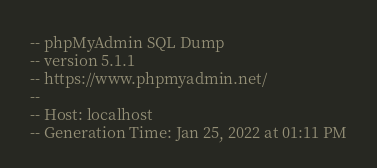<code> <loc_0><loc_0><loc_500><loc_500><_SQL_>-- phpMyAdmin SQL Dump
-- version 5.1.1
-- https://www.phpmyadmin.net/
--
-- Host: localhost
-- Generation Time: Jan 25, 2022 at 01:11 PM</code> 